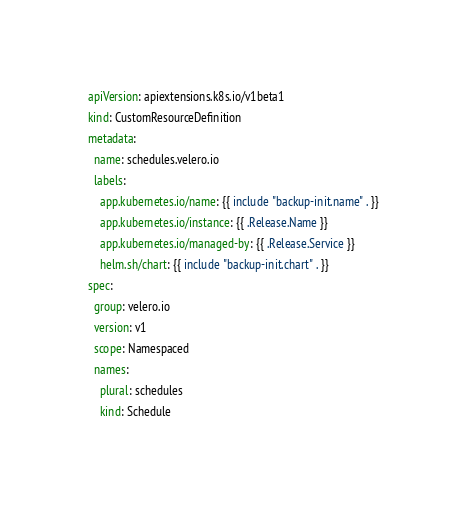<code> <loc_0><loc_0><loc_500><loc_500><_YAML_>apiVersion: apiextensions.k8s.io/v1beta1
kind: CustomResourceDefinition
metadata:
  name: schedules.velero.io
  labels:
    app.kubernetes.io/name: {{ include "backup-init.name" . }}
    app.kubernetes.io/instance: {{ .Release.Name }}
    app.kubernetes.io/managed-by: {{ .Release.Service }}
    helm.sh/chart: {{ include "backup-init.chart" . }}
spec:
  group: velero.io
  version: v1
  scope: Namespaced
  names:
    plural: schedules
    kind: Schedule
</code> 